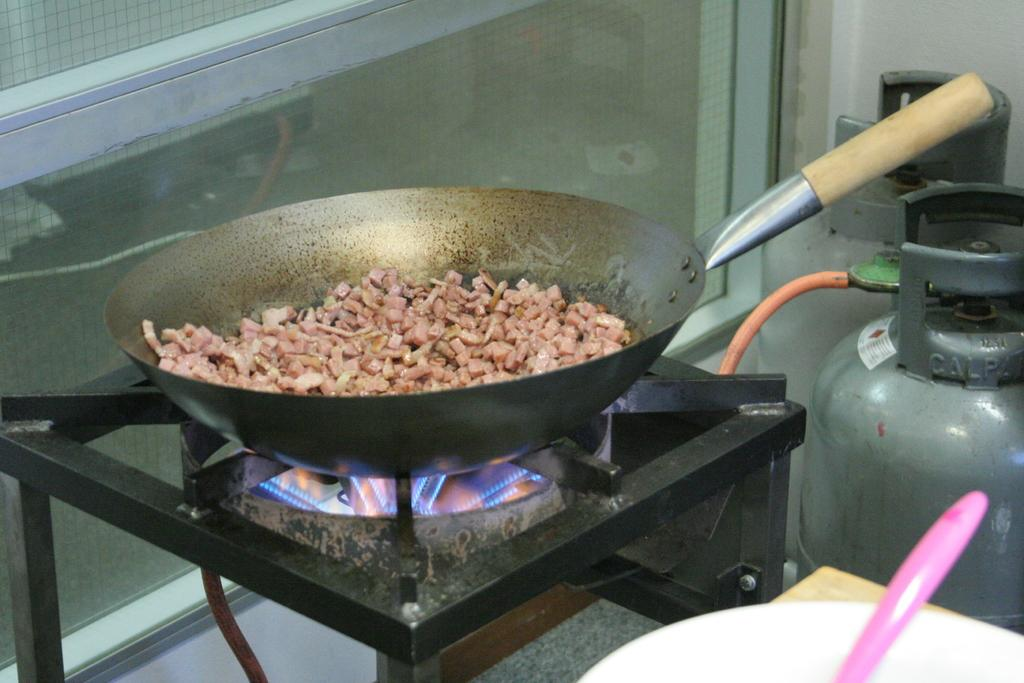What is the main object in the image? There is a stove in the image. What is the stove doing? The stove is cooking something in a cooking pan. What can be seen on the right side of the image? There are two gas cylinders on the right side of the image. What time of day is it in the image, and who is the writer? The time of day is not mentioned in the image, and there is no writer present. 